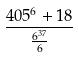Convert formula to latex. <formula><loc_0><loc_0><loc_500><loc_500>\frac { 4 0 5 ^ { 6 } + 1 8 } { \frac { 6 ^ { 3 7 } } { 6 } }</formula> 